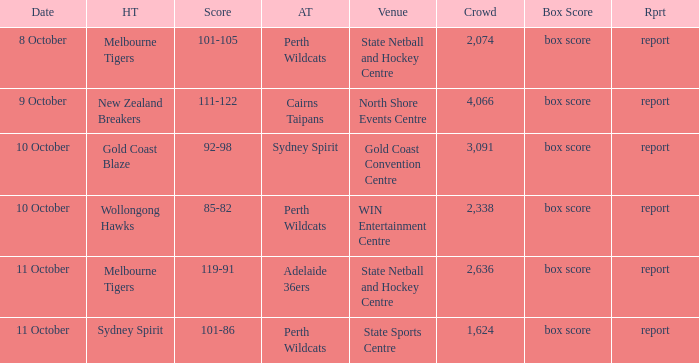What was the number of the crowd when the Wollongong Hawks were the home team? 2338.0. 